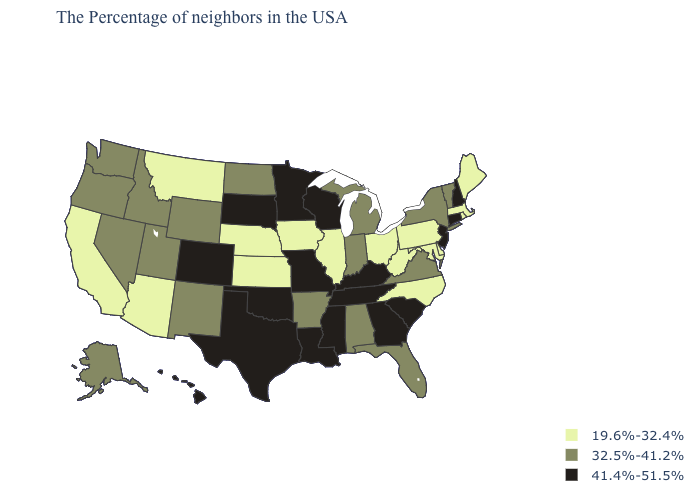What is the lowest value in states that border Texas?
Keep it brief. 32.5%-41.2%. Does the first symbol in the legend represent the smallest category?
Write a very short answer. Yes. Name the states that have a value in the range 19.6%-32.4%?
Be succinct. Maine, Massachusetts, Rhode Island, Delaware, Maryland, Pennsylvania, North Carolina, West Virginia, Ohio, Illinois, Iowa, Kansas, Nebraska, Montana, Arizona, California. Does Louisiana have the same value as Oklahoma?
Concise answer only. Yes. What is the value of Maine?
Short answer required. 19.6%-32.4%. What is the value of California?
Concise answer only. 19.6%-32.4%. Does Montana have a higher value than Utah?
Short answer required. No. Name the states that have a value in the range 41.4%-51.5%?
Keep it brief. New Hampshire, Connecticut, New Jersey, South Carolina, Georgia, Kentucky, Tennessee, Wisconsin, Mississippi, Louisiana, Missouri, Minnesota, Oklahoma, Texas, South Dakota, Colorado, Hawaii. Which states hav the highest value in the West?
Keep it brief. Colorado, Hawaii. Name the states that have a value in the range 41.4%-51.5%?
Concise answer only. New Hampshire, Connecticut, New Jersey, South Carolina, Georgia, Kentucky, Tennessee, Wisconsin, Mississippi, Louisiana, Missouri, Minnesota, Oklahoma, Texas, South Dakota, Colorado, Hawaii. Name the states that have a value in the range 19.6%-32.4%?
Give a very brief answer. Maine, Massachusetts, Rhode Island, Delaware, Maryland, Pennsylvania, North Carolina, West Virginia, Ohio, Illinois, Iowa, Kansas, Nebraska, Montana, Arizona, California. What is the value of Tennessee?
Answer briefly. 41.4%-51.5%. What is the value of Arkansas?
Short answer required. 32.5%-41.2%. Which states hav the highest value in the Northeast?
Concise answer only. New Hampshire, Connecticut, New Jersey. Name the states that have a value in the range 32.5%-41.2%?
Concise answer only. Vermont, New York, Virginia, Florida, Michigan, Indiana, Alabama, Arkansas, North Dakota, Wyoming, New Mexico, Utah, Idaho, Nevada, Washington, Oregon, Alaska. 